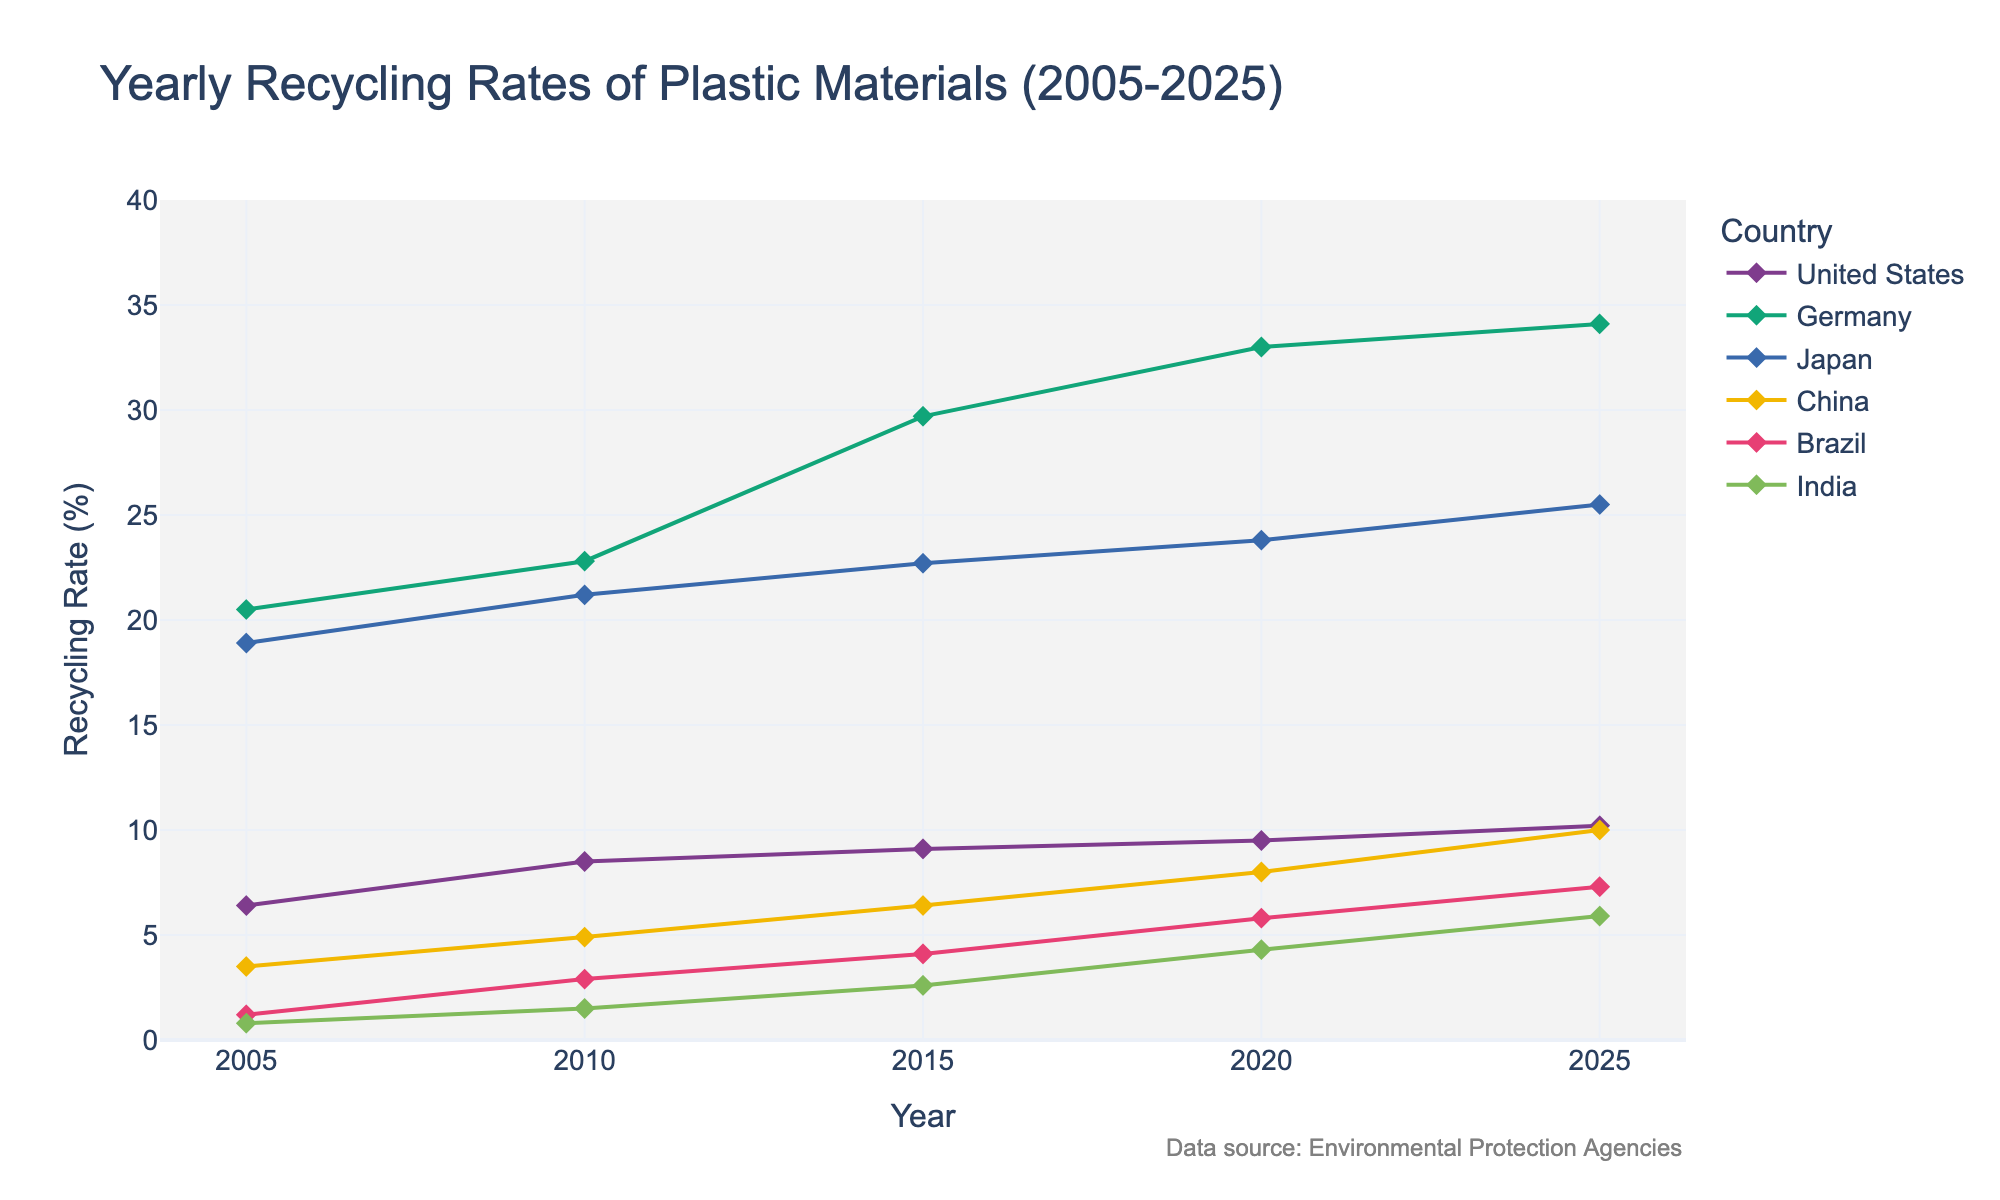How many countries are represented in the figure? By looking at the different colored lines and their labels in the legend, you can count the number of countries.
Answer: 6 What is the title of the figure? The title is displayed at the top of the figure.
Answer: Yearly Recycling Rates of Plastic Materials (2005-2025) Which country had the highest recycling rate in 2020? To determine this, look at the y-values of the different countries for the year 2020 and find the highest one.
Answer: Germany What is the overall trend of recycling rates for the United States from 2005 to 2025? Observe the pattern of the line corresponding to the United States over the years; note if it is increasing, decreasing, or stable.
Answer: Increasing In which year did Japan's recycling rate surpass 20%? Identify the year by looking at Japan's line and finding the first year it crosses the 20% mark on the y-axis.
Answer: 2010 Calculate the change in recycling rate for China from the year 2005 to 2025. Subtract China's recycling rate in 2005 from its rate in 2025. 10.0 (2025) - 3.5 (2005) = 6.5
Answer: 6.5% Which country showed the most significant increase in recycling rate between 2005 and 2020? Compare the differences in recycling rates for each country between 2005 and 2020 by subtracting the respective values and identify the largest increase.
Answer: Germany By how much did Brazil's recycling rate increase from 2010 to 2015? Subtract Brazil's recycling rate in 2010 from its rate in 2015. 4.1 (2015) - 2.9 (2010) = 1.2
Answer: 1.2% Which countries had a recycling rate lower than 10% in 2025? Identify the countries by looking at the y-values for the year 2025 and noting which ones are less than 10%.
Answer: Brazil, India, United States Compare the recycling rates of Japan and Germany in 2015. Which is higher? Look at the y-values for both Japan and Germany in 2015 and compare them.
Answer: Germany 